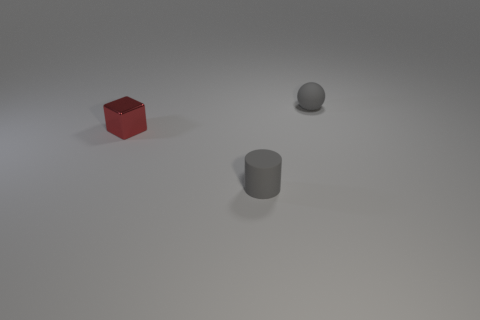Is there any other thing that has the same material as the red cube?
Offer a very short reply. No. What number of things are the same color as the tiny matte cylinder?
Your response must be concise. 1. What is the size of the red metallic cube that is behind the matte object in front of the metal cube?
Keep it short and to the point. Small. The red thing has what shape?
Offer a very short reply. Cube. There is a object that is on the left side of the cylinder; what is it made of?
Provide a short and direct response. Metal. There is a rubber object that is to the left of the gray thing that is behind the small gray rubber object in front of the small red metal block; what color is it?
Your answer should be compact. Gray. There is a metallic block that is the same size as the matte cylinder; what is its color?
Ensure brevity in your answer.  Red. How many rubber things are gray balls or red cylinders?
Keep it short and to the point. 1. The small thing that is the same material as the gray ball is what color?
Keep it short and to the point. Gray. There is a small gray object that is behind the gray object in front of the tiny gray ball; what is its material?
Your answer should be compact. Rubber. 